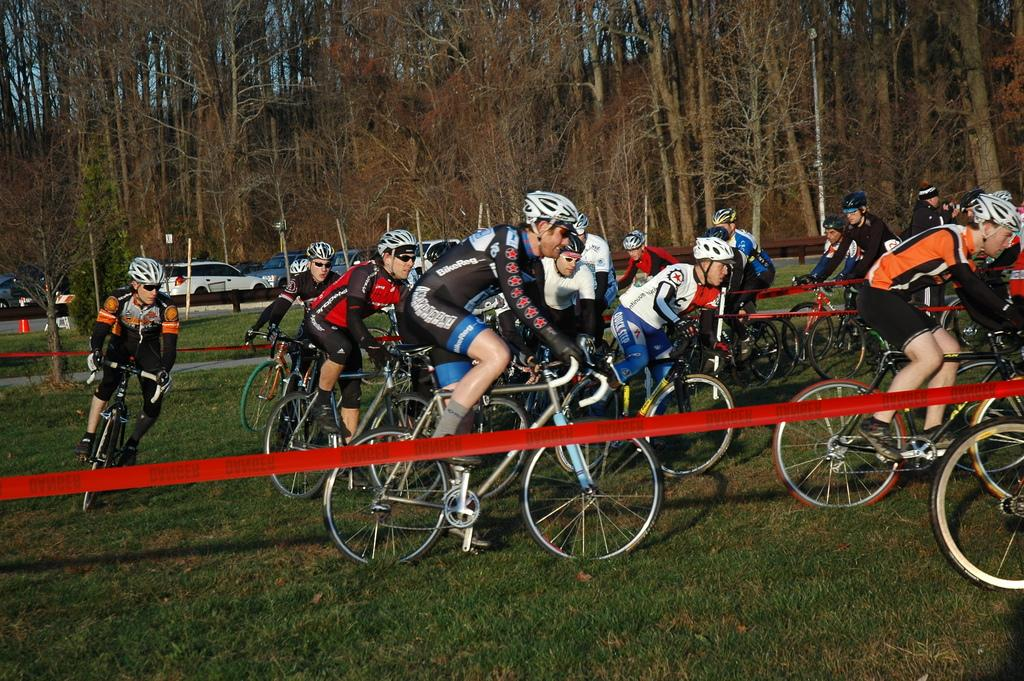Who is present in the image? There are people in the image. What are the people wearing? The people are wearing helmets. What activity are the people engaged in? The people are riding bicycles. What else can be seen in the image besides the people? There are other vehicles and trees in the image. What type of vegetation is present in the image? There are plants in the image. Can you see any jellyfish swimming in the image? No, there are no jellyfish present in the image. What type of bait is being used by the people in the image? There is no mention of fishing or bait in the image; the people are riding bicycles. 